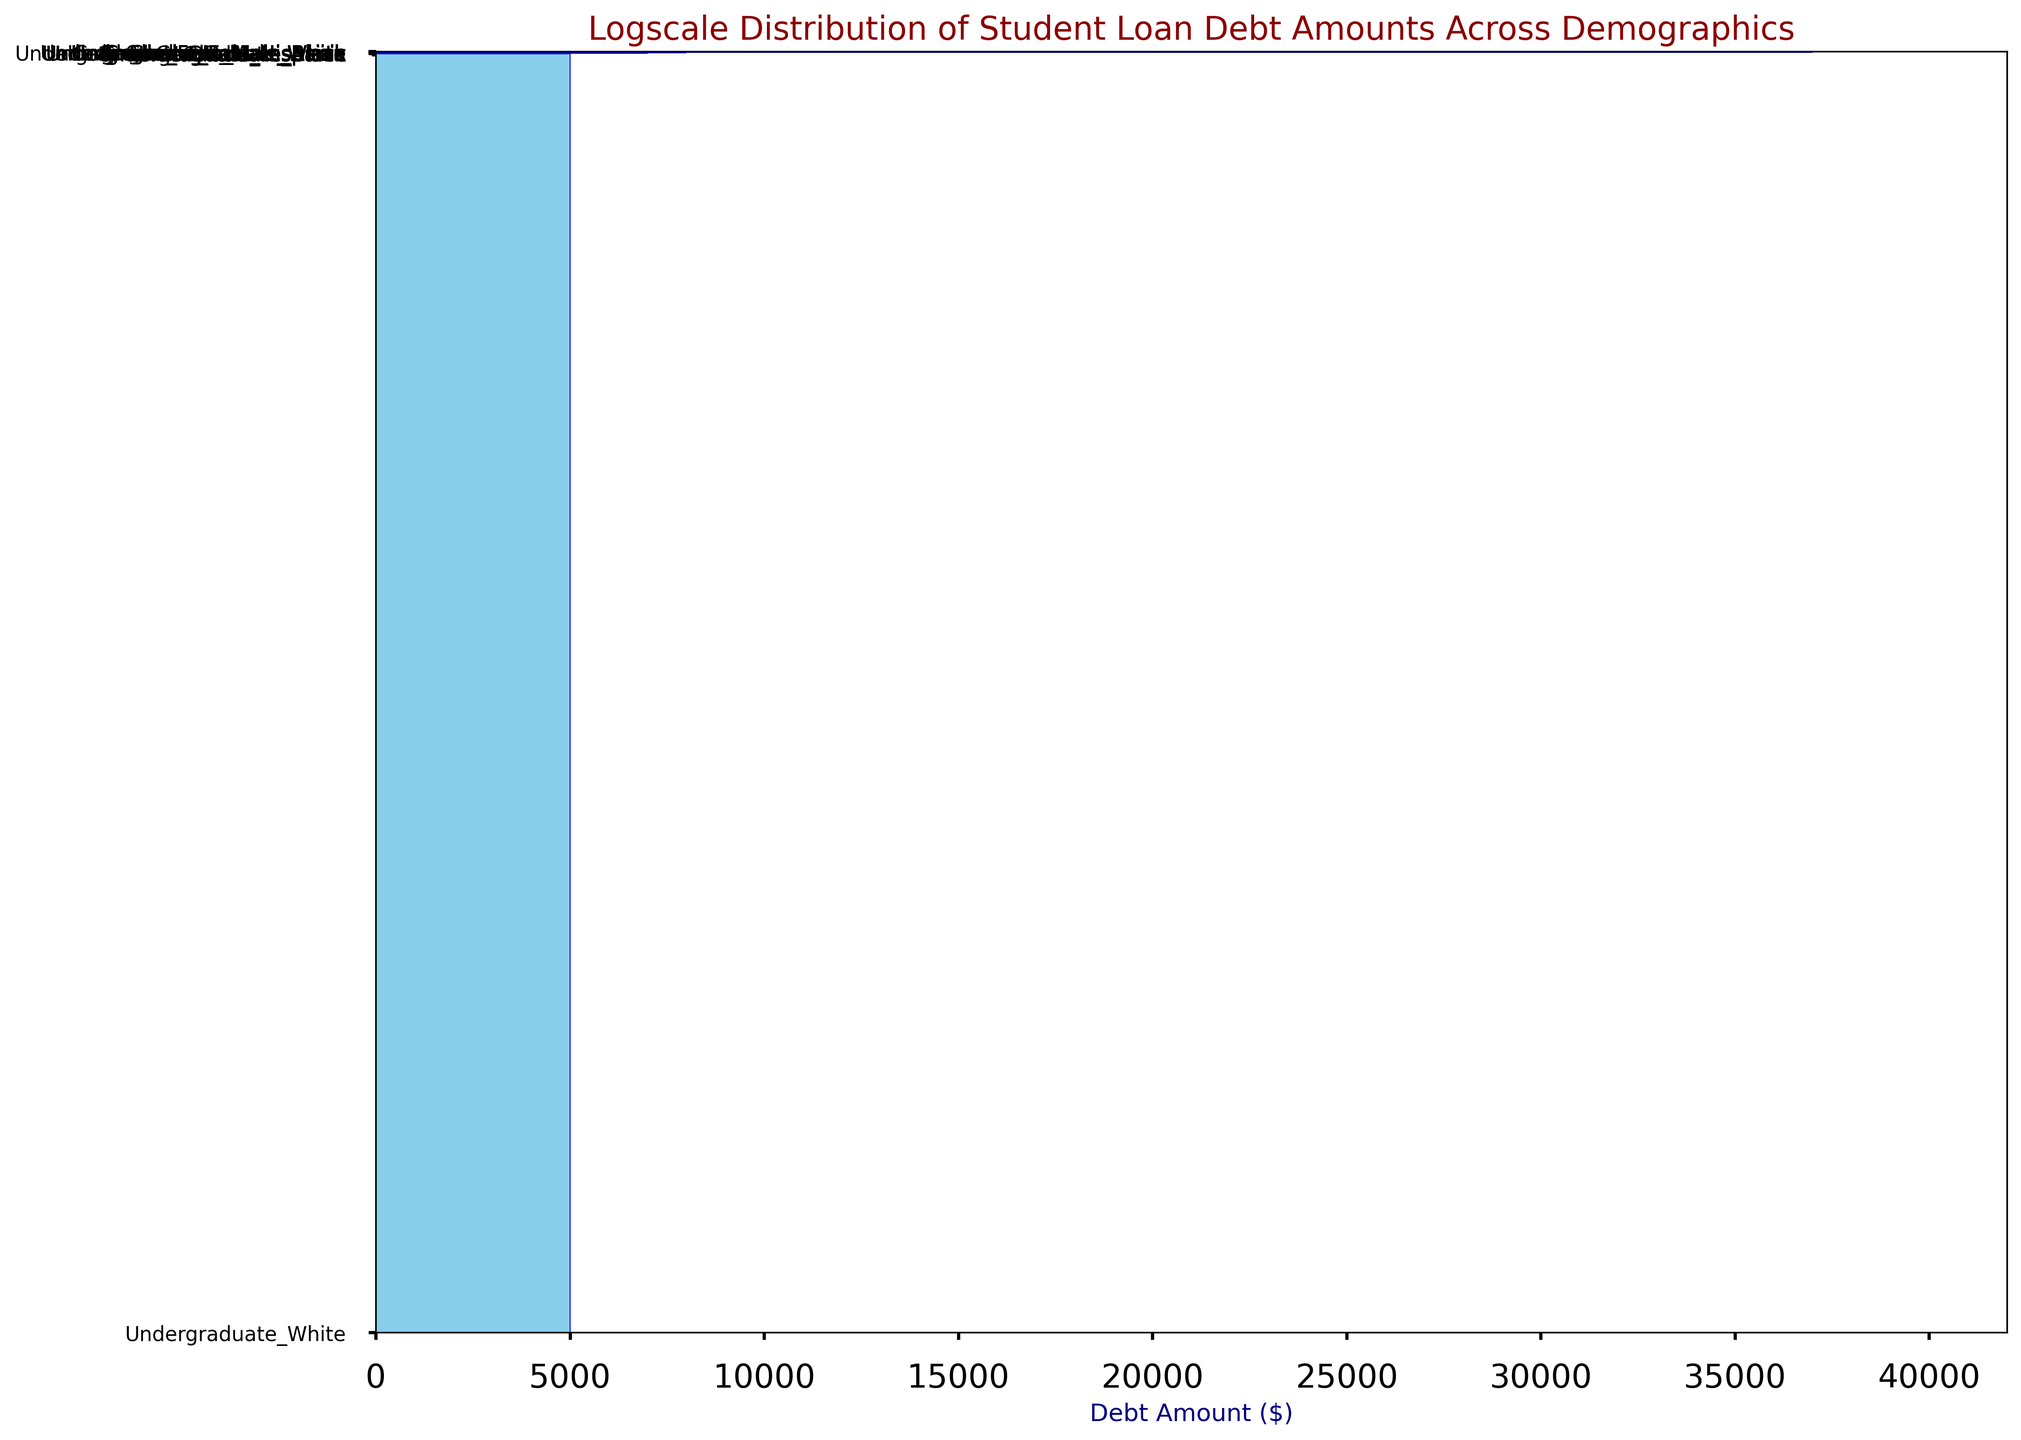What demographic has the highest amount of student loan debt? The figure shows the debt amount for various demographics. To find the highest, we compare the heights of the bars. The bar for Graduate_Female_Black is the highest, indicating this demographic has the highest debt.
Answer: Graduate_Female_Black What is the difference in student loan debt between Undergraduate_White and Graduate_White? Look at the heights of the bars for Undergraduate_White and Graduate_White. Undergraduate_White has a debt amount of $5000, and Graduate_White has $25000. The difference is $25000 - $5000.
Answer: $20000 Which demographic has the lowest amount of student loan debt? By comparing the bar heights, the demographic with the lowest debt is Undergraduate_Male_Asian, as its bar is the shortest.
Answer: Undergraduate_Male_Asian What is the average student loan debt for all undergraduate demographics? Sum the debt amounts for all undergraduate demographics and divide by the number of these demographics. The amounts are $5000, $7000, $8000, $3000, $6000, $8000, $9000, $4000, $4000, $6000, $7000, $2000. The sum is $63000 and there are 12 undergraduate demographics. The average is $63000 / 12.
Answer: $5250 How does the student loan debt for Graduate_Female_Hispanic compare to Graduate_Male_Hispanic? Compare the heights of their respective bars. Graduate_Female_Hispanic has a debt of $22000, and Graduate_Male_Hispanic has $18000. Graduate_Female_Hispanic's debt is higher.
Answer: Graduate_Female_Hispanic's debt is higher What is the total student loan debt for all Graduate_Female demographics? Sum the debt amounts for all Graduate_Female demographics: $27000 (White), $40000 (Black), $22000 (Hispanic), $15000 (Asian). The total is $27000 + $40000 + $22000 + $15000.
Answer: $104000 Which undergraduate gender has more student loan debt within the White demographic? Compare the debt amounts for Undergraduate_Female_White and Undergraduate_Male_White. Undergraduate_Female_White has $6000, while Undergraduate_Male_White has $4000. Therefore, the Female group has more debt.
Answer: Undergraduate_Female_White Are there more undergraduate or graduate demographics listed in the chart? Count the number of demographics for undergraduate and graduate categories. There are 12 undergraduate demographics and 8 graduate demographics.
Answer: More undergraduate demographics What is the ratio of student loan debt between Graduate_Black and Undergraduate_Black? Graduate_Black debt amount is $37000, and Undergraduate_Black is $7000. The ratio is $37000 / $7000.
Answer: Approximately 5.29 How does the debt amount for Undergraduate_Female_Asian compare to Undergraduate_Male_Asian? Compare the bar heights for Undergraduate_Female_Asian ($4000) and Undergraduate_Male_Asian ($2000). Undergraduate_Female_Asian's debt is higher.
Answer: Undergraduate_Female_Asian's debt is higher 